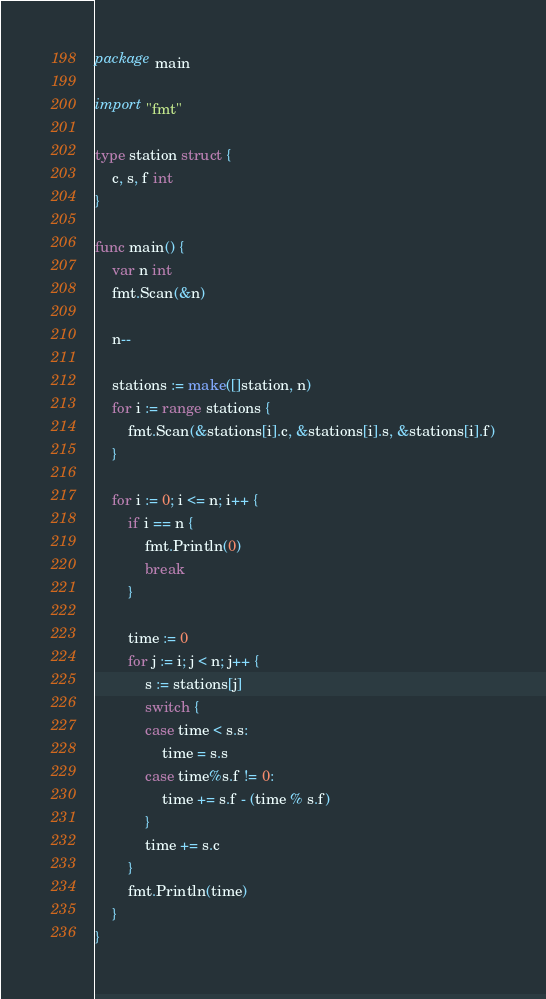<code> <loc_0><loc_0><loc_500><loc_500><_Go_>package main

import "fmt"

type station struct {
	c, s, f int
}

func main() {
	var n int
	fmt.Scan(&n)

	n--

	stations := make([]station, n)
	for i := range stations {
		fmt.Scan(&stations[i].c, &stations[i].s, &stations[i].f)
	}

	for i := 0; i <= n; i++ {
		if i == n {
			fmt.Println(0)
			break
		}

		time := 0
		for j := i; j < n; j++ {
			s := stations[j]
			switch {
			case time < s.s:
				time = s.s
			case time%s.f != 0:
				time += s.f - (time % s.f)
			}
			time += s.c
		}
		fmt.Println(time)
	}
}
</code> 